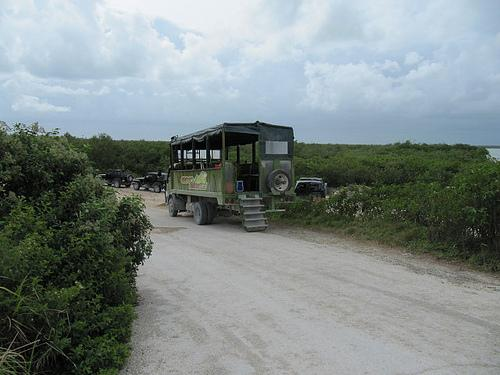What is the condition of the road in the image? The road is light brown, dusty, and dry. Mention the presence of natural elements in the image. There are green bushes, a tree, and a cloudy sky in the image. Identify the color of the vehicle present in the image. The vehicle is green in color. What can you infer about the environment and setting of this image? The image is set in an outdoor environment, with a dusty road surrounded by green bushes and a tree, under a cloudy sky. Count the number of wheels mentioned in the image description. There are four wheels described in the image. What kind of transportation is parked in the image? There is a green truck parked in the image. Explain the interaction between the truck and the road. The green truck is parked on a light brown, dusty, and dry road. Describe the weather and sky conditions in the image. The sky is grey with puffy clouds, indicating a cloudy day. What is the state of the stairs in the image? The stairs are small and grey, and they are positioned on the truck. Describe the sentiment or mood conveyed by the image. The image conveys a calm and quiet atmosphere, with a parked truck on a dusty road surrounded by nature under a cloudy sky. 